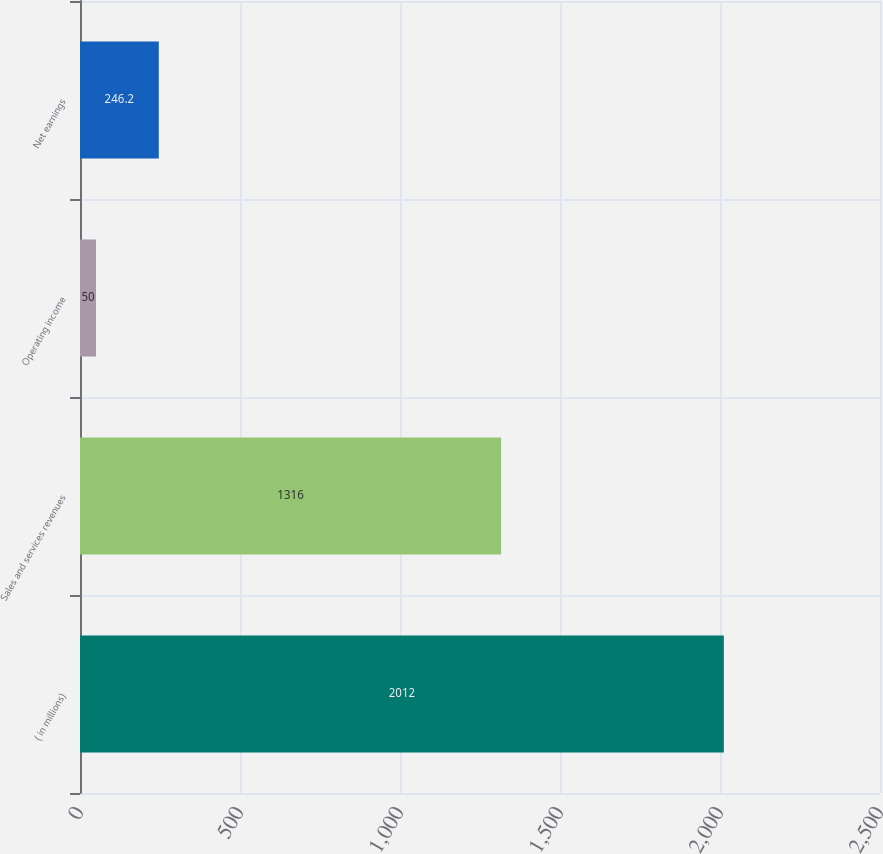<chart> <loc_0><loc_0><loc_500><loc_500><bar_chart><fcel>( in millions)<fcel>Sales and services revenues<fcel>Operating income<fcel>Net earnings<nl><fcel>2012<fcel>1316<fcel>50<fcel>246.2<nl></chart> 